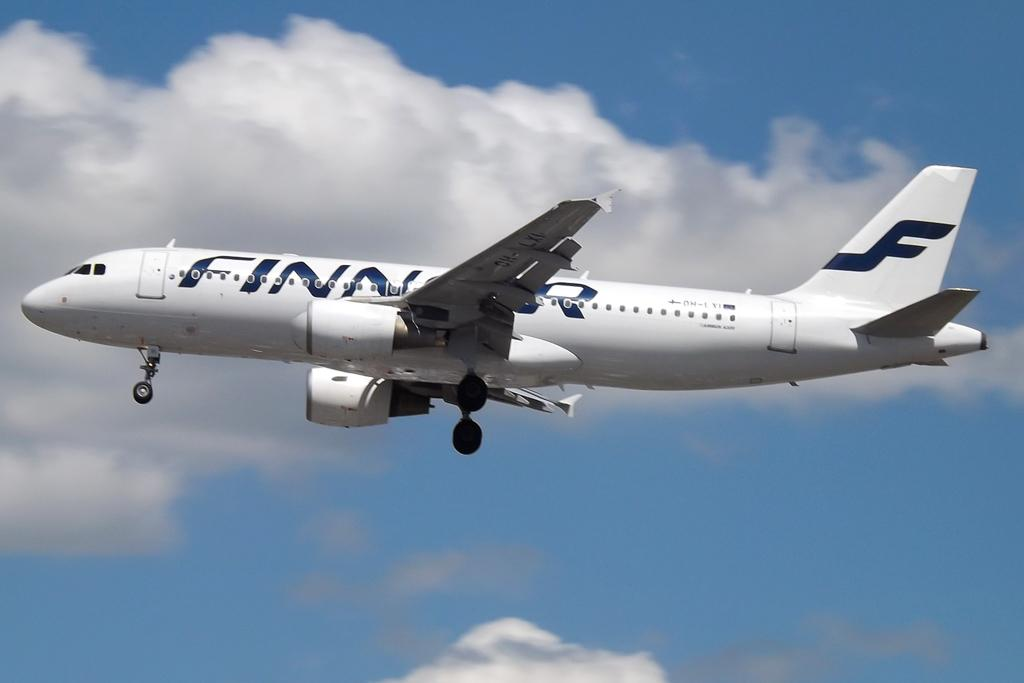<image>
Summarize the visual content of the image. A white Finnair plane's company name is painted in blue on the fuselage. 